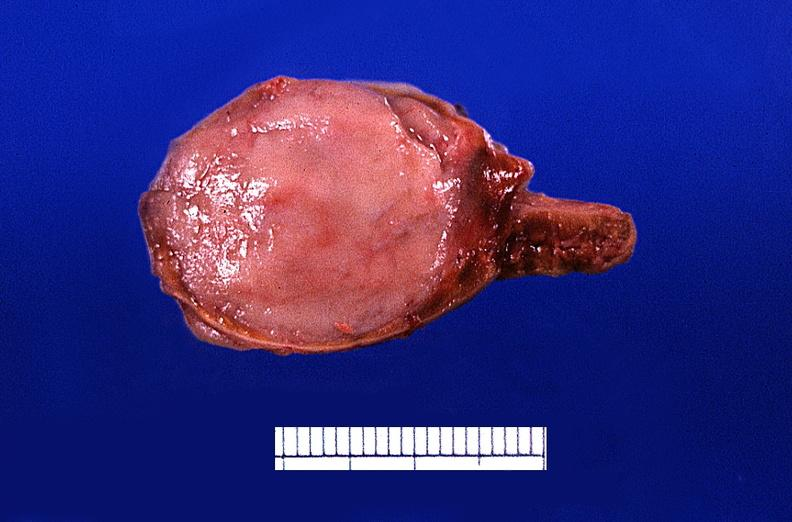what does this image show?
Answer the question using a single word or phrase. Adrenal medullary tumor 